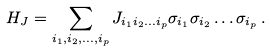Convert formula to latex. <formula><loc_0><loc_0><loc_500><loc_500>H _ { J } = \sum _ { i _ { 1 } , i _ { 2 } , \dots , i _ { p } } J _ { i _ { 1 } i _ { 2 } \dots i _ { p } } \sigma _ { i _ { 1 } } \sigma _ { i _ { 2 } } \dots \sigma _ { i _ { p } } \, .</formula> 